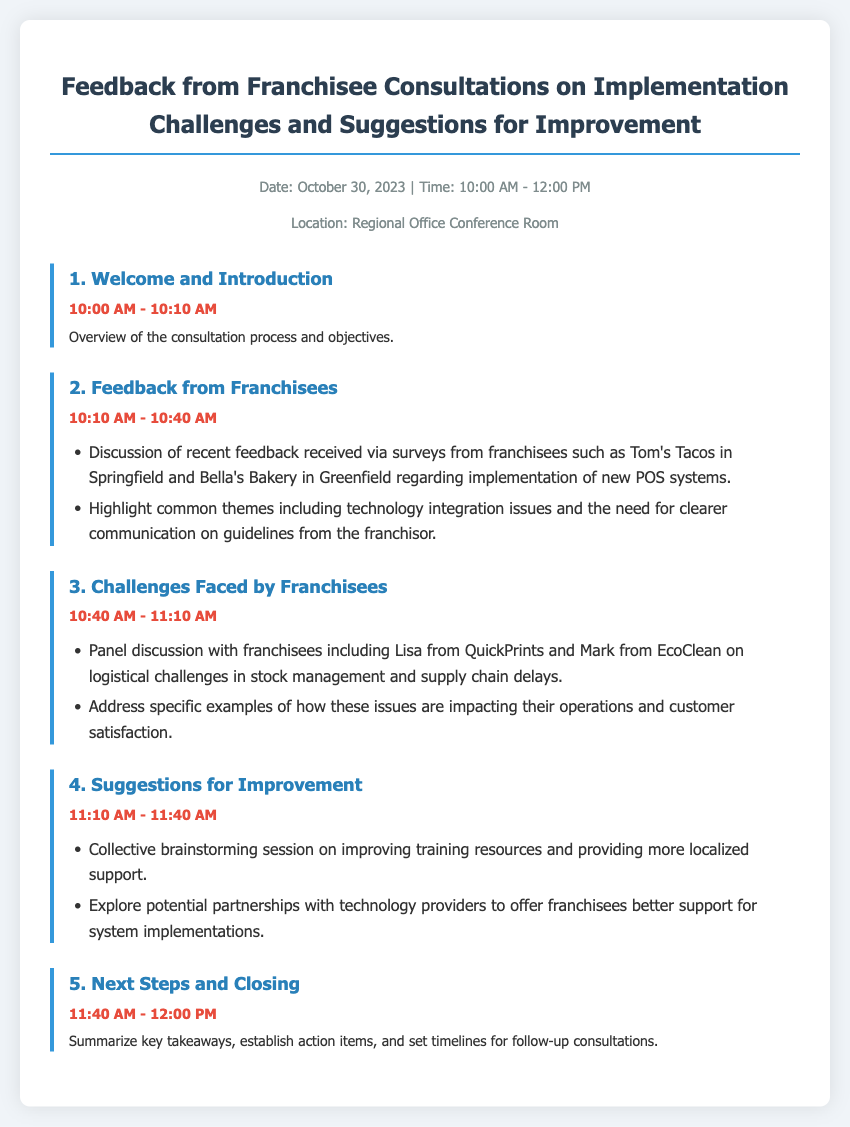What is the date of the consultation? The date of the consultation is mentioned at the top of the document.
Answer: October 30, 2023 What time does the consultation start? The start time is indicated in the header section of the document.
Answer: 10:00 AM Who is the franchisee from QuickPrints? This information can be found in the "Challenges Faced by Franchisees" section discussing participants.
Answer: Lisa What are the two common themes highlighted in the feedback? The themes are listed in the "Feedback from Franchisees" section, detailing issues reported by the franchisees.
Answer: Technology integration issues and clearer communication What is the duration of the Suggestions for Improvement session? The duration can be calculated from the start and end times provided for that agenda item.
Answer: 30 minutes How many items are listed in the agenda? The total number of agenda items can be counted from the document's structure.
Answer: 5 What will be summarized in the closing section? The closing section is meant to encapsulate specific outcomes as detailed in the last agenda item.
Answer: Key takeaways Which franchisee is associated with EcoClean? This information is found under the "Challenges Faced by Franchisees" section with the name of a specific franchisee.
Answer: Mark What initiative is suggested for better system implementations? The suggestions include a specific approach to improve franchisee support mentioned in the "Suggestions for Improvement" section.
Answer: Partnerships with technology providers 